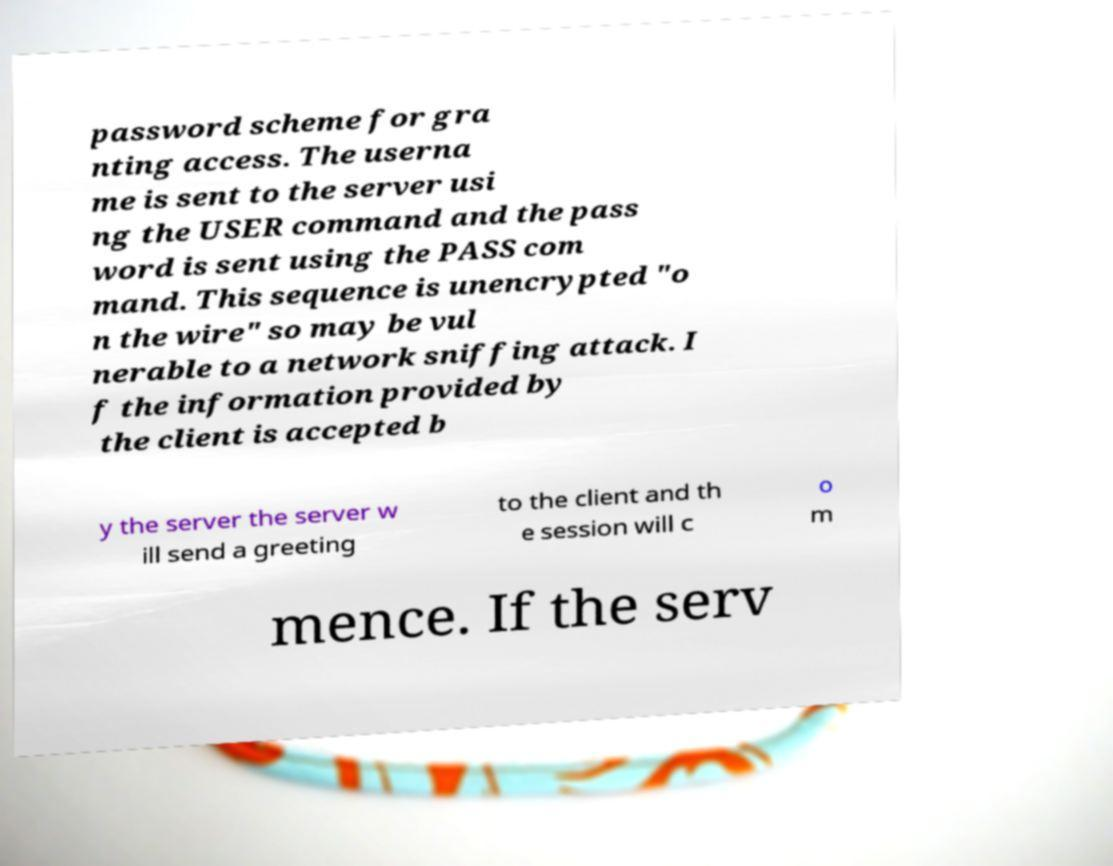Can you accurately transcribe the text from the provided image for me? password scheme for gra nting access. The userna me is sent to the server usi ng the USER command and the pass word is sent using the PASS com mand. This sequence is unencrypted "o n the wire" so may be vul nerable to a network sniffing attack. I f the information provided by the client is accepted b y the server the server w ill send a greeting to the client and th e session will c o m mence. If the serv 